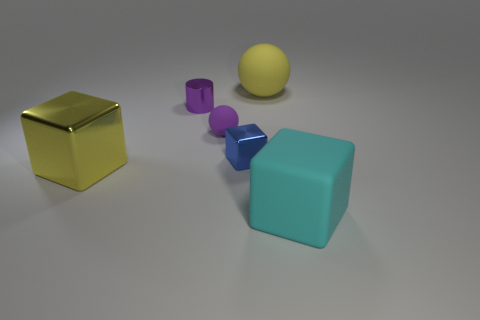There is a thing that is on the right side of the big thing behind the big yellow block; how many large yellow rubber objects are behind it?
Offer a terse response. 1. What is the size of the other shiny object that is the same shape as the small blue thing?
Give a very brief answer. Large. Are there fewer large yellow metallic blocks left of the small cylinder than gray metal cylinders?
Provide a short and direct response. No. Is the shape of the yellow metallic object the same as the cyan rubber object?
Provide a short and direct response. Yes. The tiny shiny thing that is the same shape as the big yellow metallic thing is what color?
Provide a short and direct response. Blue. How many tiny shiny things have the same color as the small rubber thing?
Provide a short and direct response. 1. How many objects are big things to the right of the yellow ball or big yellow things?
Provide a succinct answer. 3. There is a matte object behind the tiny sphere; what size is it?
Provide a succinct answer. Large. Is the number of big yellow metallic things less than the number of tiny purple objects?
Make the answer very short. Yes. Do the large cyan object right of the tiny purple sphere and the ball to the right of the small blue object have the same material?
Offer a terse response. Yes. 